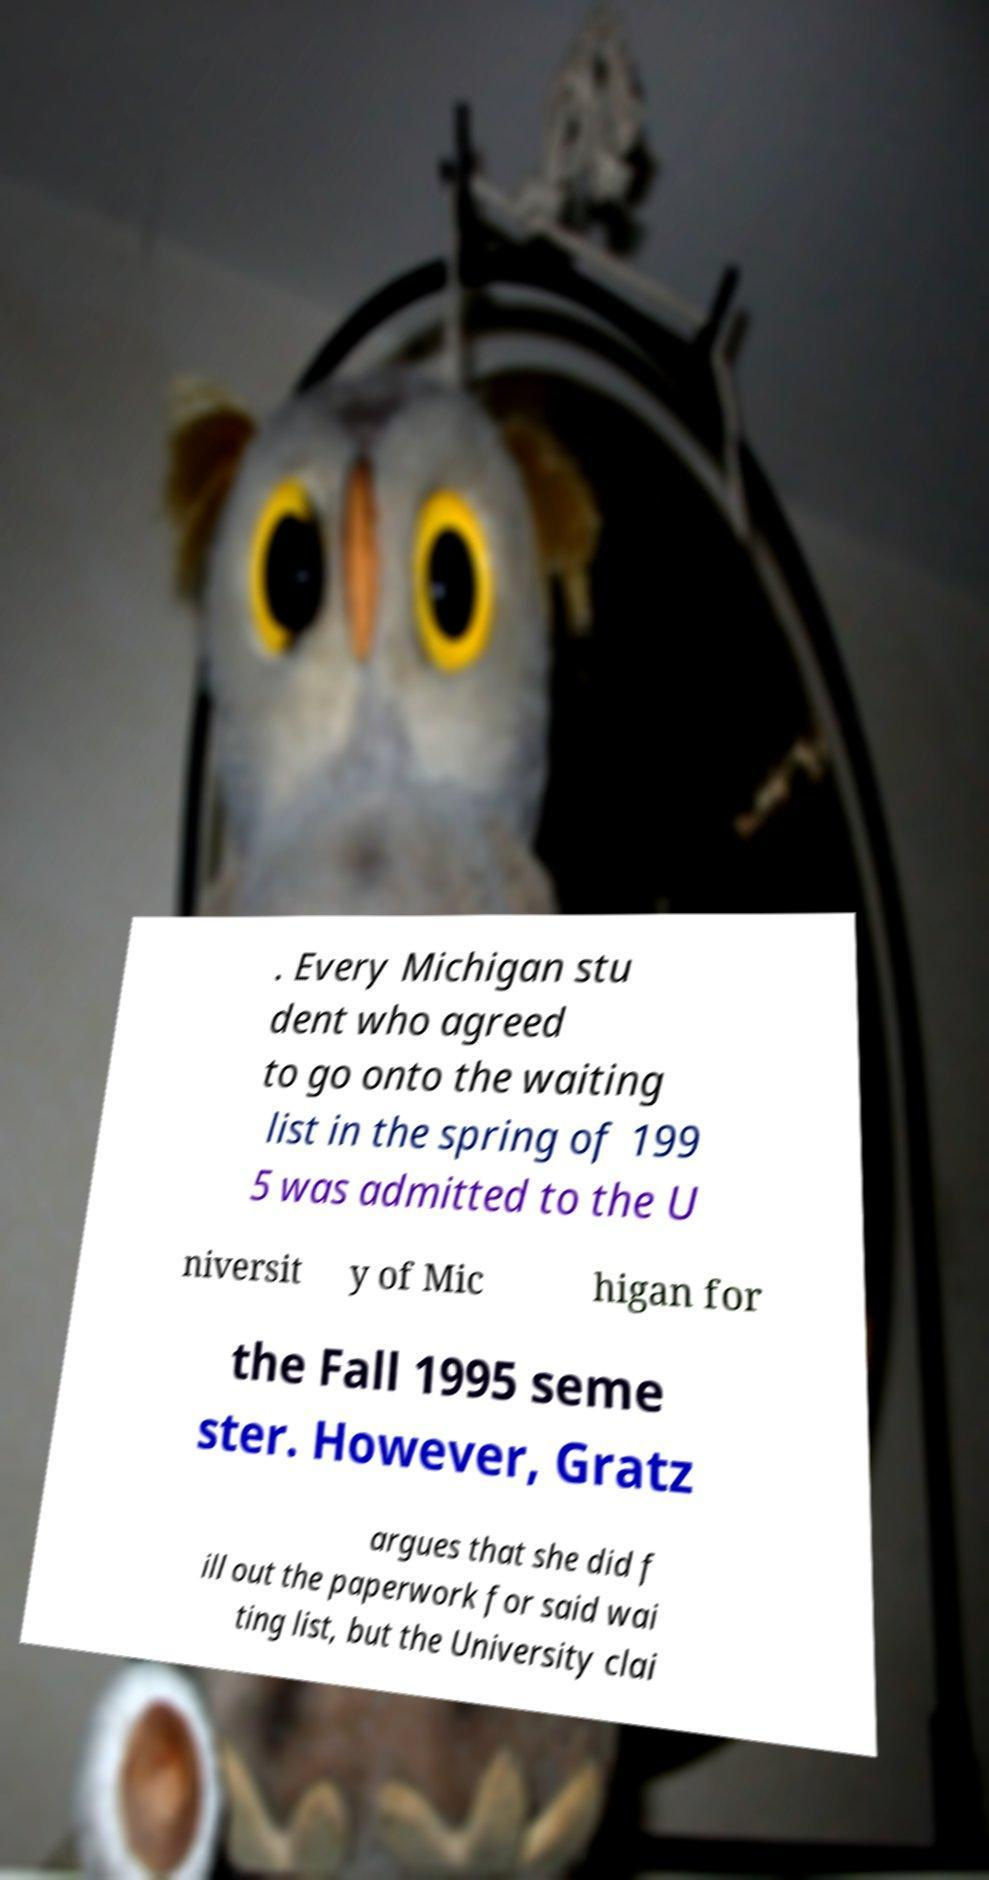Could you extract and type out the text from this image? . Every Michigan stu dent who agreed to go onto the waiting list in the spring of 199 5 was admitted to the U niversit y of Mic higan for the Fall 1995 seme ster. However, Gratz argues that she did f ill out the paperwork for said wai ting list, but the University clai 